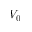<formula> <loc_0><loc_0><loc_500><loc_500>V _ { 0 }</formula> 